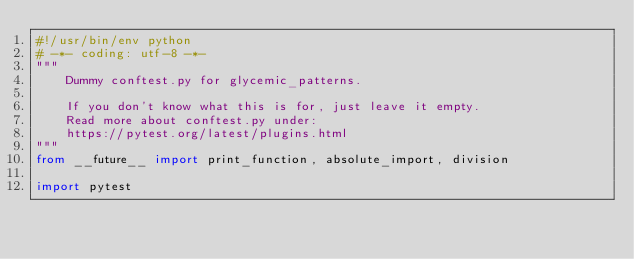Convert code to text. <code><loc_0><loc_0><loc_500><loc_500><_Python_>#!/usr/bin/env python
# -*- coding: utf-8 -*-
"""
    Dummy conftest.py for glycemic_patterns.

    If you don't know what this is for, just leave it empty.
    Read more about conftest.py under:
    https://pytest.org/latest/plugins.html
"""
from __future__ import print_function, absolute_import, division

import pytest
</code> 